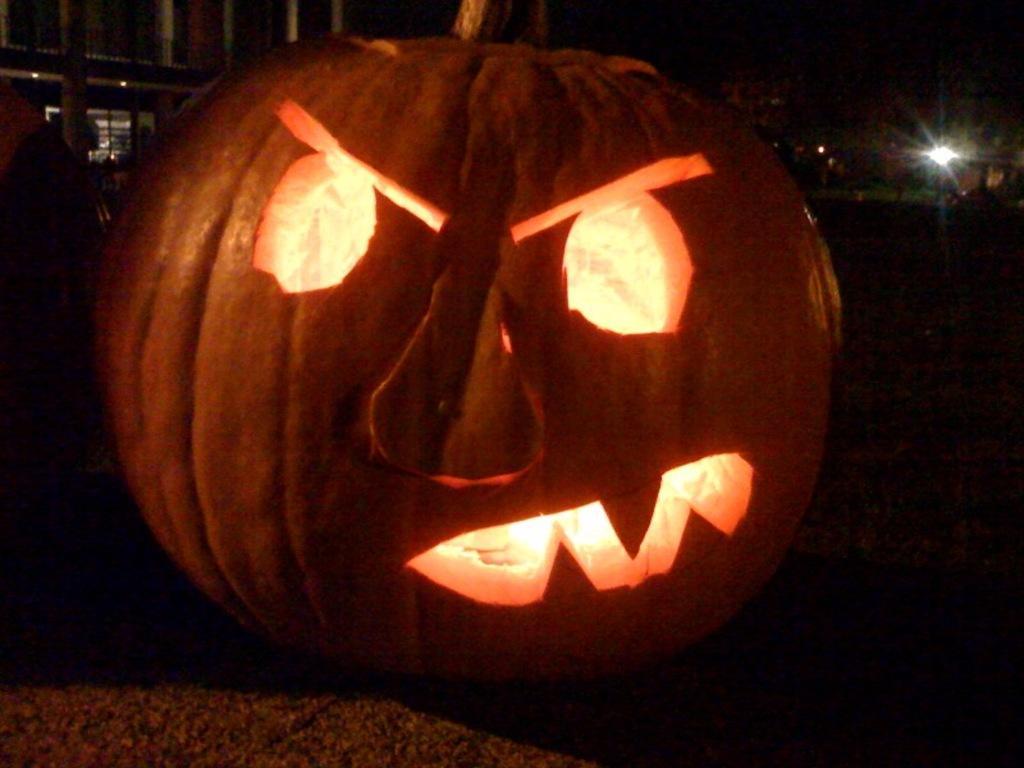In one or two sentences, can you explain what this image depicts? There is a light in the pumpkin. Which is cut in the shape of personal space and is on the ground. In the background, there are lights and there is a building. And the background is dark in color. 